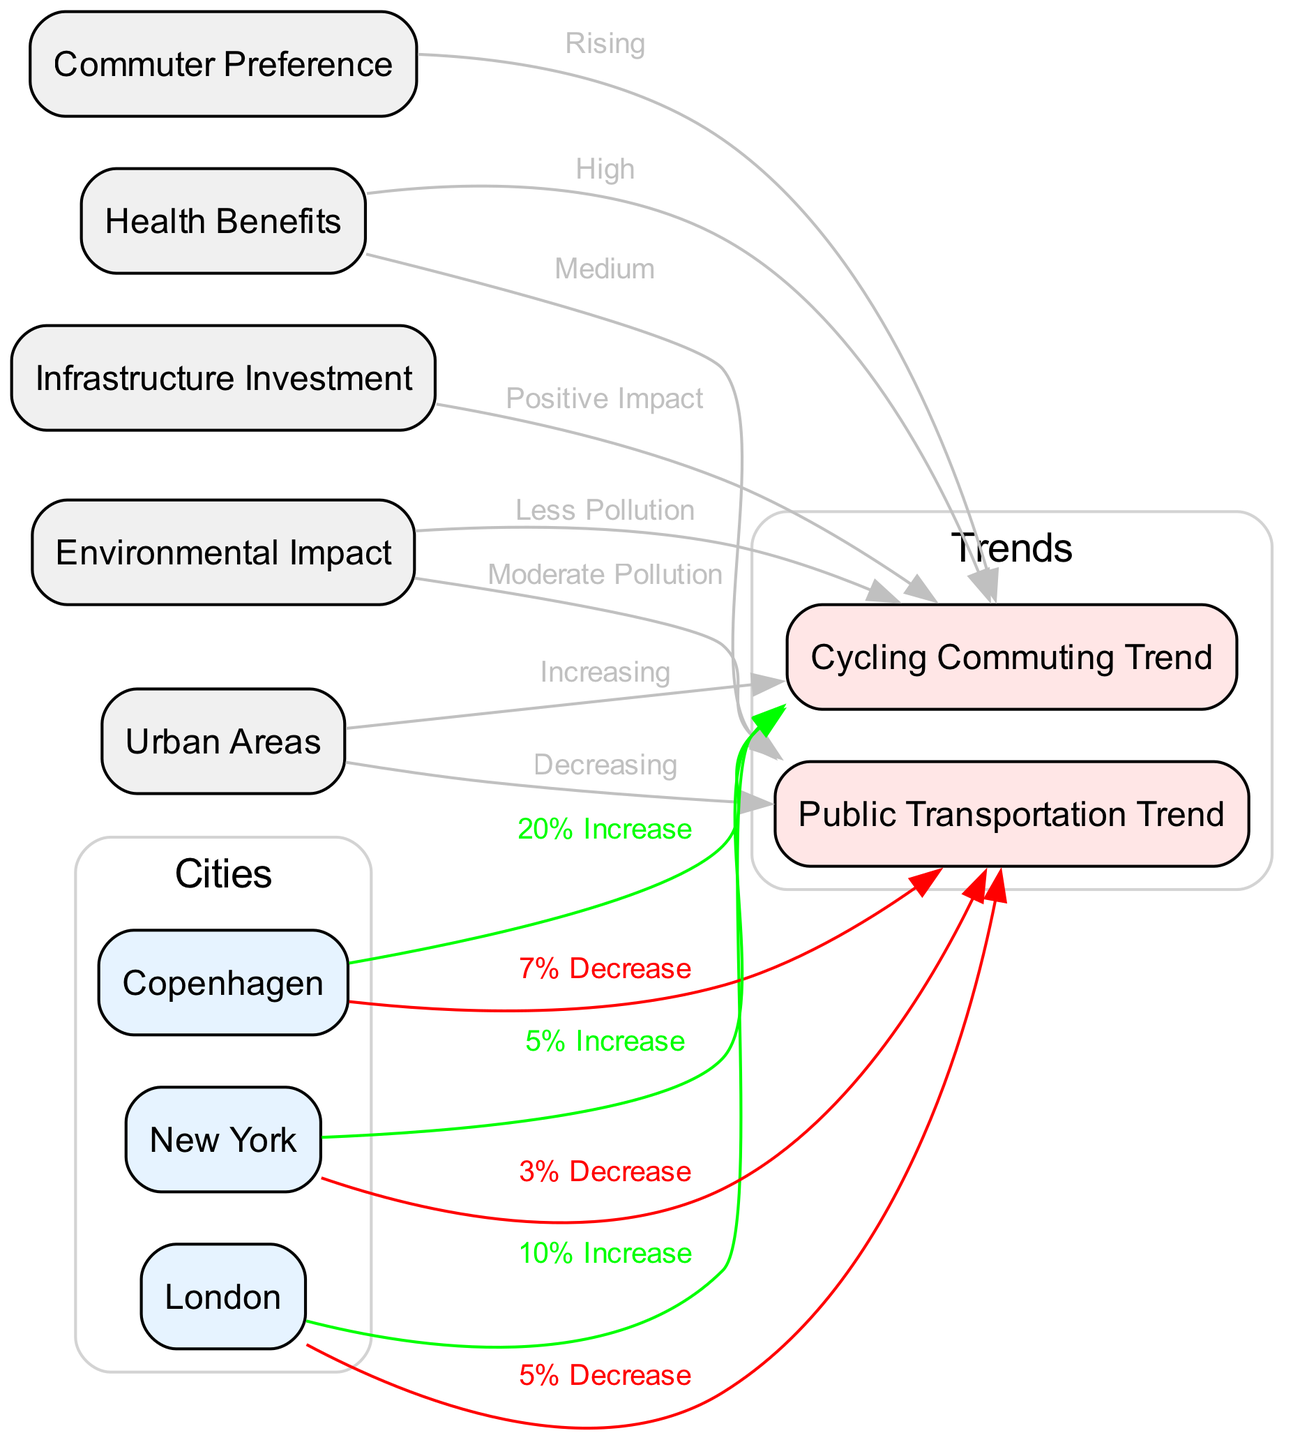What trend is observed in cycling commuting within urban areas? The diagram indicates that there is an "Increasing" trend in cycling commuting in urban areas, as represented by the positive relationship from "urban_areas" to "cycling_commuting_trend."
Answer: Increasing What percentage increase in cycling commuting is reported for Copenhagen? The edge from "city_copenhagen" to "cycling_commuting_trend" states a "20% Increase," which directly answers the percentage increase.
Answer: 20% Increase What type of impact does infrastructure investment have on cycling commuting trends? The connection from "infrastructure_investment" to "cycling_commuting_trend" indicates a "Positive Impact," showing how infrastructure affects cycling commuting positively.
Answer: Positive Impact How does public transportation trend change in urban areas? The diagram shows that public transportation is experiencing a "Decreasing" trend within urban areas, indicated by the relationship from "urban_areas" to "public_transportation_trend."
Answer: Decreasing What is the health benefit level associated with public transportation according to the diagram? The connection from "health_benefits" to "public_transportation_trend" indicates that the health benefit level is "Medium," providing insight into the health aspect of public transport.
Answer: Medium Which city reports the lowest percentage decrease in public transportation? By comparing the decreases listed for each city, the edge from "city_new_york" to "public_transportation_trend" shows a "3% Decrease," which is the lowest among the cities.
Answer: 3% Decrease What is the environmental impact associated with cycling commuting trends? The diagram demonstrates a positive relationship where "Less Pollution" is noted as an impact flowing from "environmental_impact" to "cycling_commuting_trend."
Answer: Less Pollution Which city has an increase in cycling commuting but also a decrease in public transportation? Both "city_london" and "city_copenhagen" have increases in cycling commuting and decreases in public transportation, but specifying the city with a notable percentage change requires checking each connection. London has a "10% Increase" in cycling commuting and a "5% Decrease" in public transportation.
Answer: London What overall influence does commuter preference have on cycling commuting trends? The diagram illustrates that "Rising" commuter preference positively influences the "cycling_commuting_trend," showing that more people prefer cycling as a commuting option.
Answer: Rising 